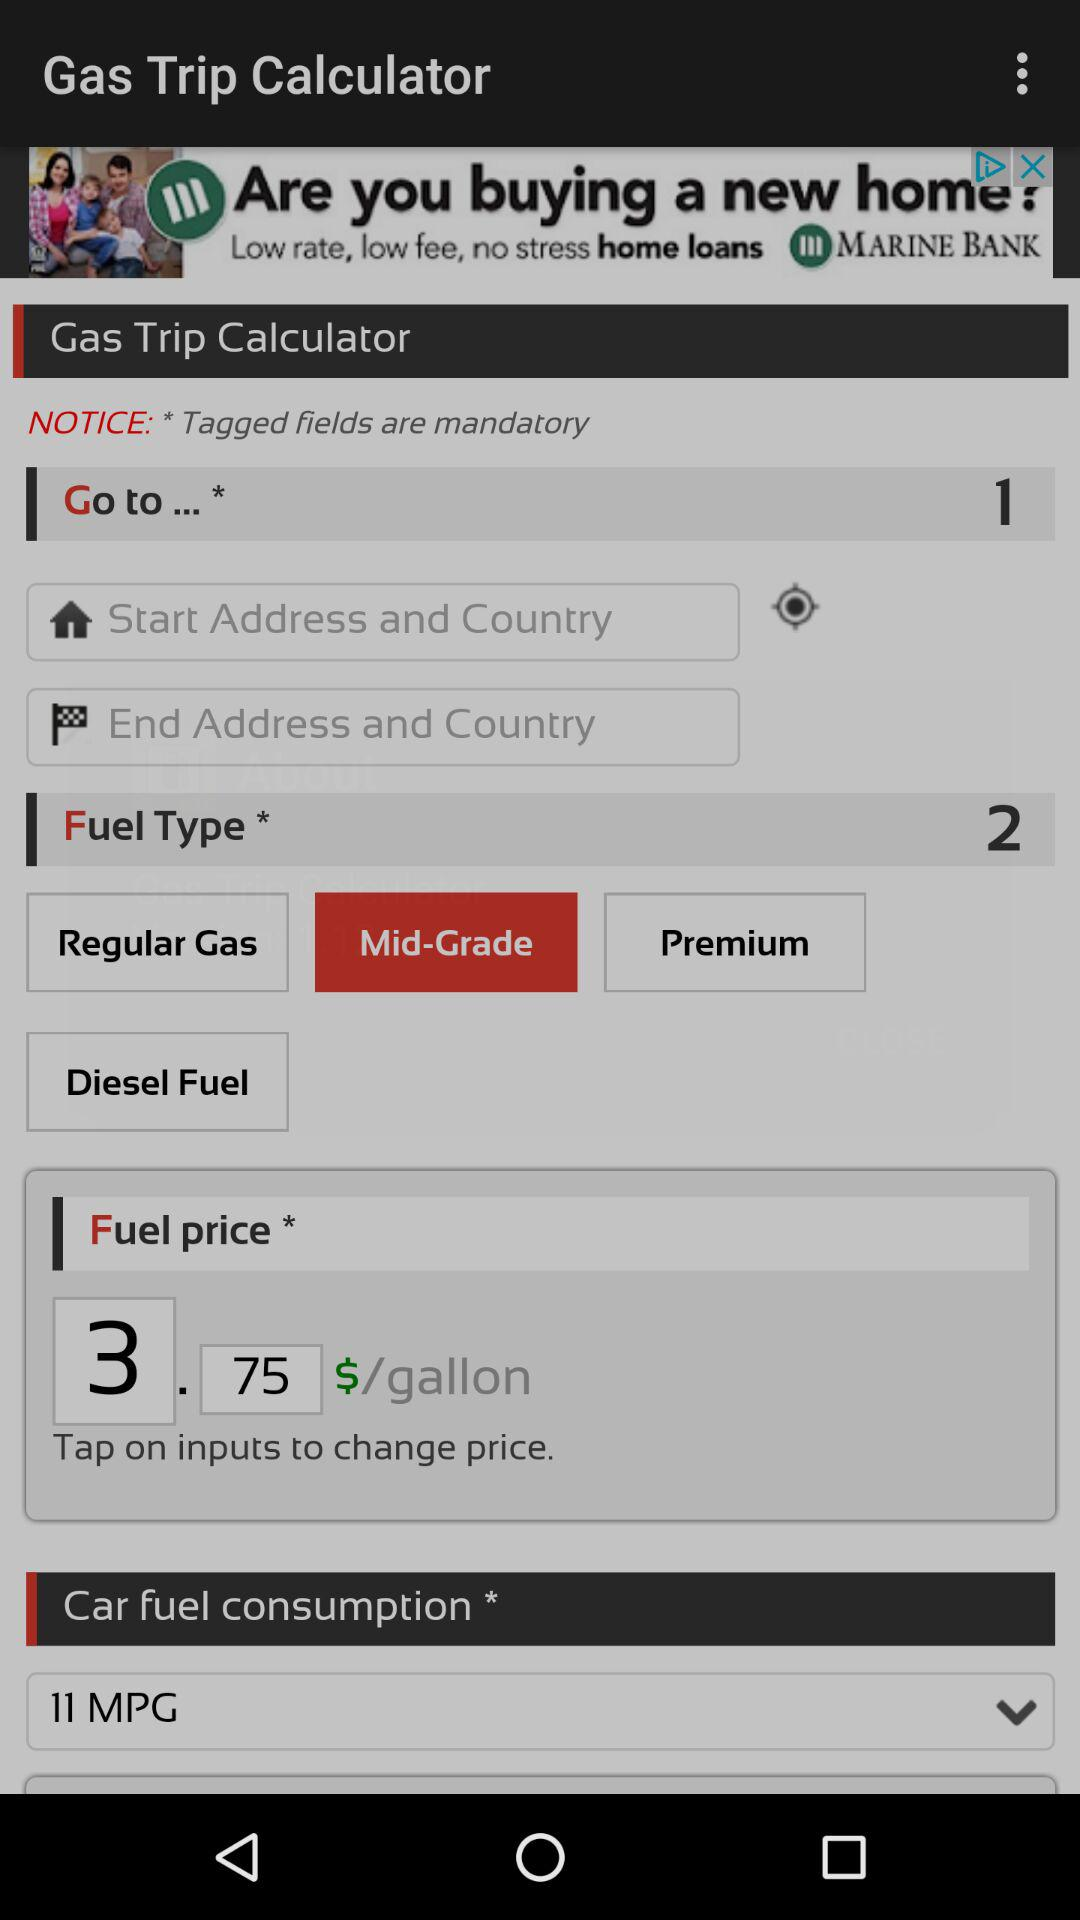Which options are available in "Fuel Type"? The available options are "Regular Gas", "Mid-Grade", "Premium" and "Diesel Fuel". 